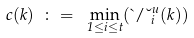<formula> <loc_0><loc_0><loc_500><loc_500>c ( k ) \ \colon = \ \min _ { 1 \leq i \leq t } ( \theta / \lambda ^ { u } _ { i } ( k ) )</formula> 